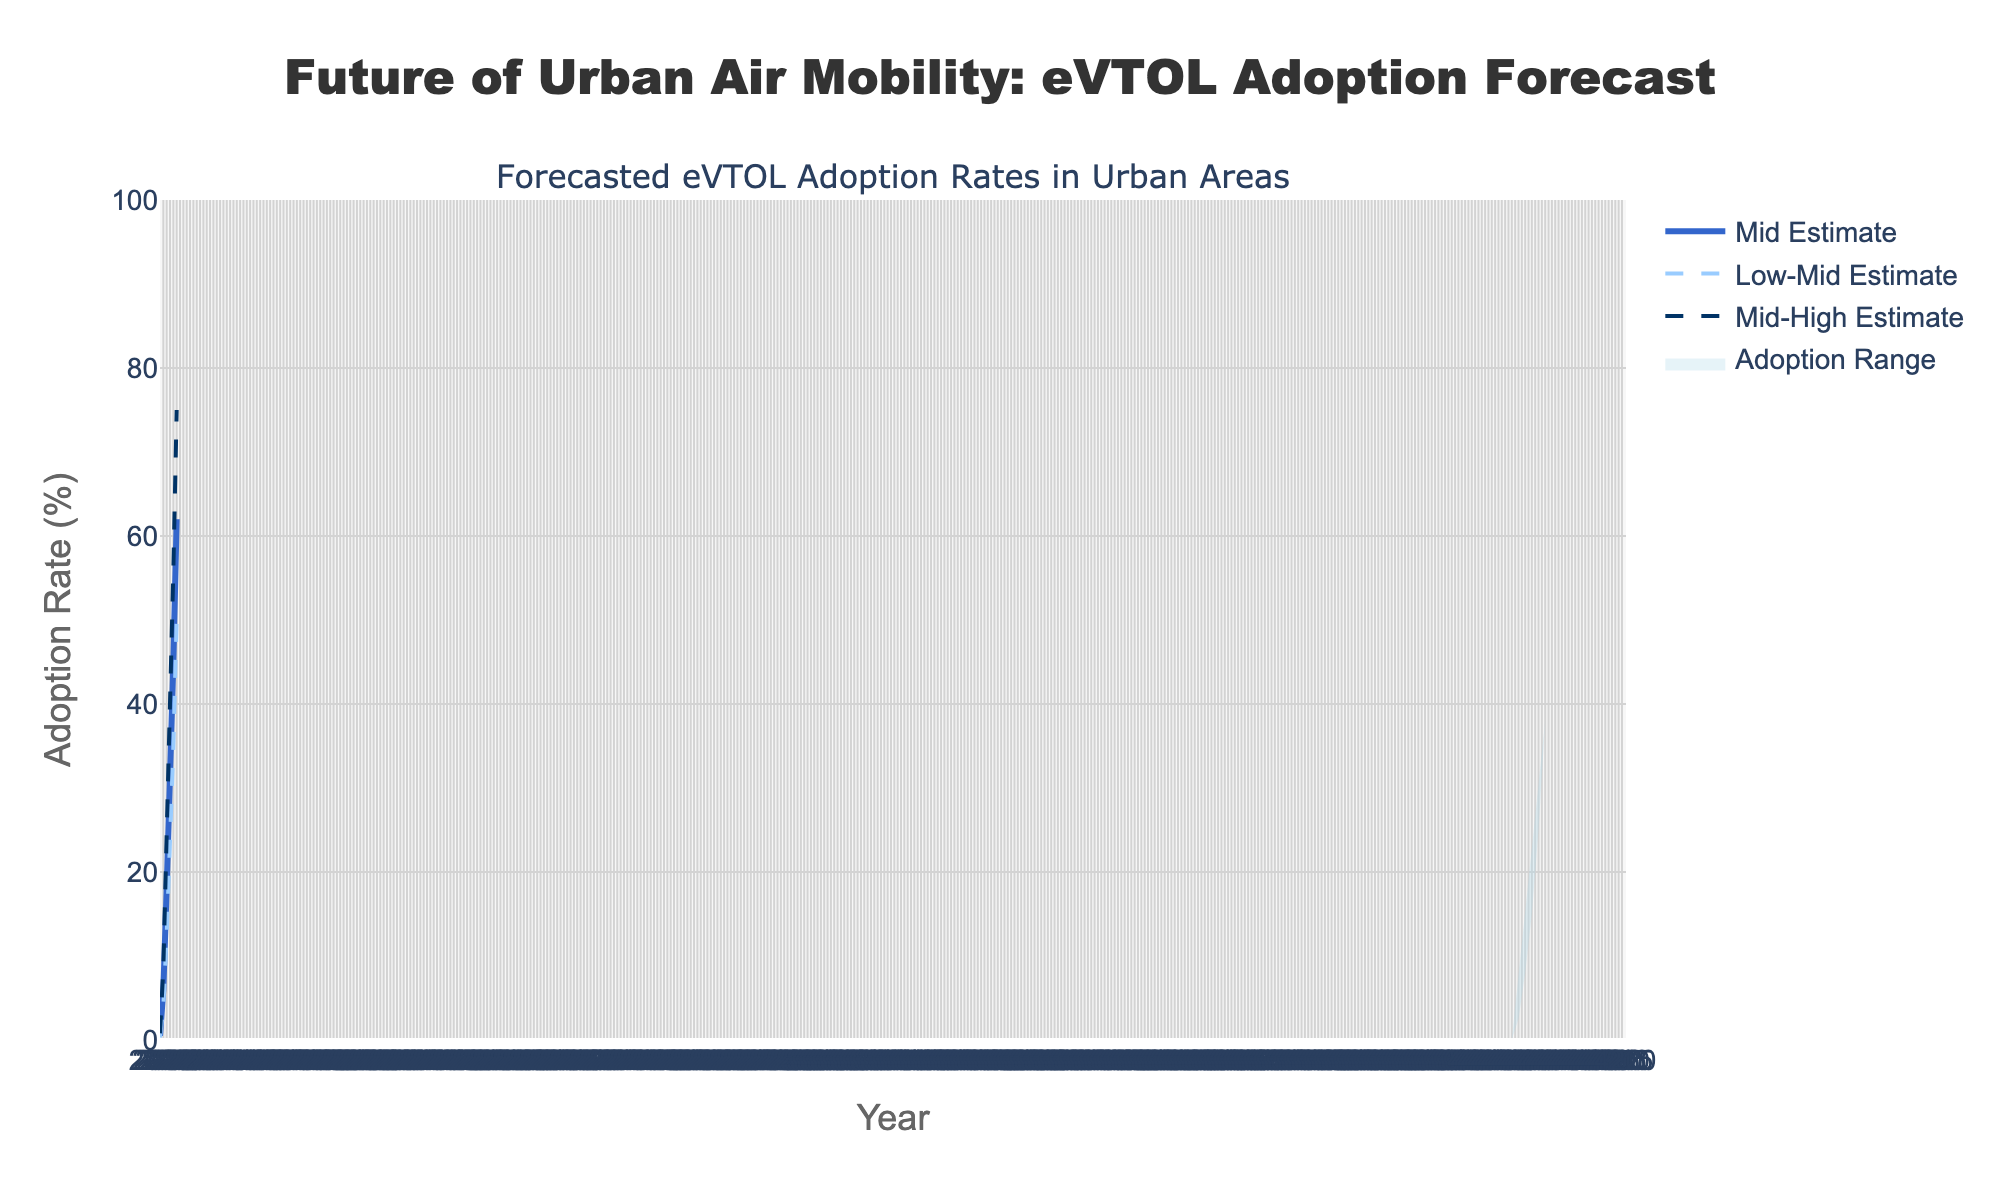What is the title of the figure? The title of the figure is displayed at the top of the chart, indicated by a larger and bolder font size. The title text is "Future of Urban Air Mobility: eVTOL Adoption Forecast".
Answer: Future of Urban Air Mobility: eVTOL Adoption Forecast What is the forecasted mid estimate adoption rate for eVTOL aircraft in the year 2030? Look at the "Mid Estimate" trace, find the year 2030 on the x-axis, and then trace vertically up to the mid estimate value. The value for 2030 is 6.0%.
Answer: 6.0% In which year does the high estimate reach 70% adoption rate? Identify the "High Estimate" trace, and follow it until you reach the value of 70%. Trace downward to find the corresponding year on the x-axis. The year for 70% adoption is 2045.
Answer: 2045 By how much does the low estimate increase from 2025 to 2050? Find the low estimate values for both 2025 and 2050 and calculate the difference. The low estimate in 2025 is 0.1%, and in 2050 it is 38.0%. So, 38.0% - 0.1% = 37.9%.
Answer: 37.9% What is the range of adoption rates in 2040? To find the range, look at the values for the low and high estimates in 2040 and calculate the difference between them. The low estimate is 15.0%, and the high estimate is 50.0%, so the range is 50.0% - 15.0% = 35.0%.
Answer: 35.0% Which estimate has the steepest increase between 2025 and 2030? Compare the increases of all estimates (Low, Low-Mid, Mid, Mid-High, High) from 2025 to 2030, by subtracting the values in 2025 from the values in 2030. The increases are as follows: Low: 2.4%, Low-Mid: 3.7%, Mid: 5.5%, Mid-High: 7.7%, High: 10.8%. The high estimate has the steepest increase.
Answer: High Estimate How does the mid estimate adoption rate in 2045 compare to the low-mid estimate adoption rate in 2050? Look at the mid estimate value for 2045 and the low-mid estimate value for 2050. The mid estimate in 2045 is 45.0%, while the low-mid estimate in 2050 is 50.0%. Therefore, the low-mid estimate in 2050 is higher.
Answer: Lower What is the adoption rate range for eVTOL aircraft in 2025? The adoption rate range in 2025 can be determined by the low and high estimates. The low estimate is 0.1% and the high estimate is 1.2%. The range is the difference between these values: 1.2% - 0.1% = 1.1%.
Answer: 1.1% What trend do you observe about the adoption rates from 2025 to 2050 across all estimates? Observing the progression of all estimates from 2025 to 2050, all estimates show an upward trend, indicating increasing adoption rates over time. The increase becomes more pronounced in later years.
Answer: Increasing What is the average of the mid estimates for the years provided? Sum up the mid estimates from 2025 to 2050 and divide by the number of years. (0.5 + 6.0 + 18.0 + 30.0 + 45.0 + 62.0) / 6 = 26.92%.
Answer: 26.92% 